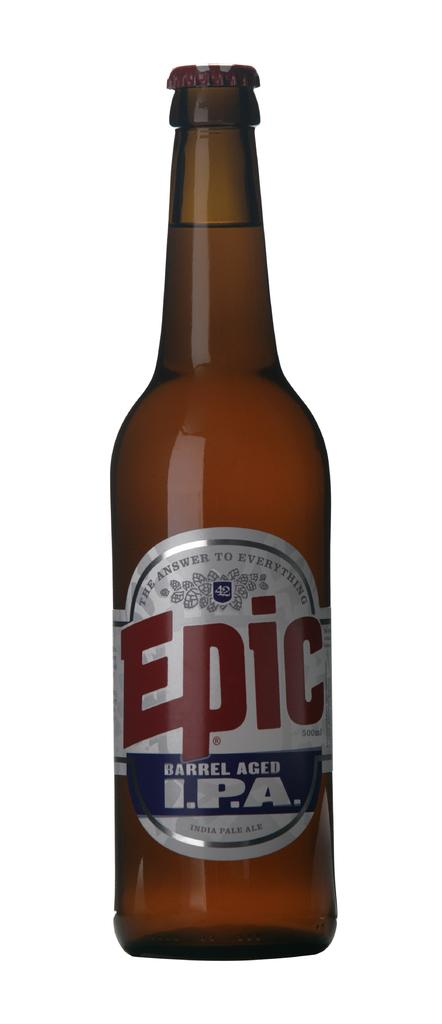<image>
Share a concise interpretation of the image provided. A brown bottle of Epic beer which is "Barrel Aged" 